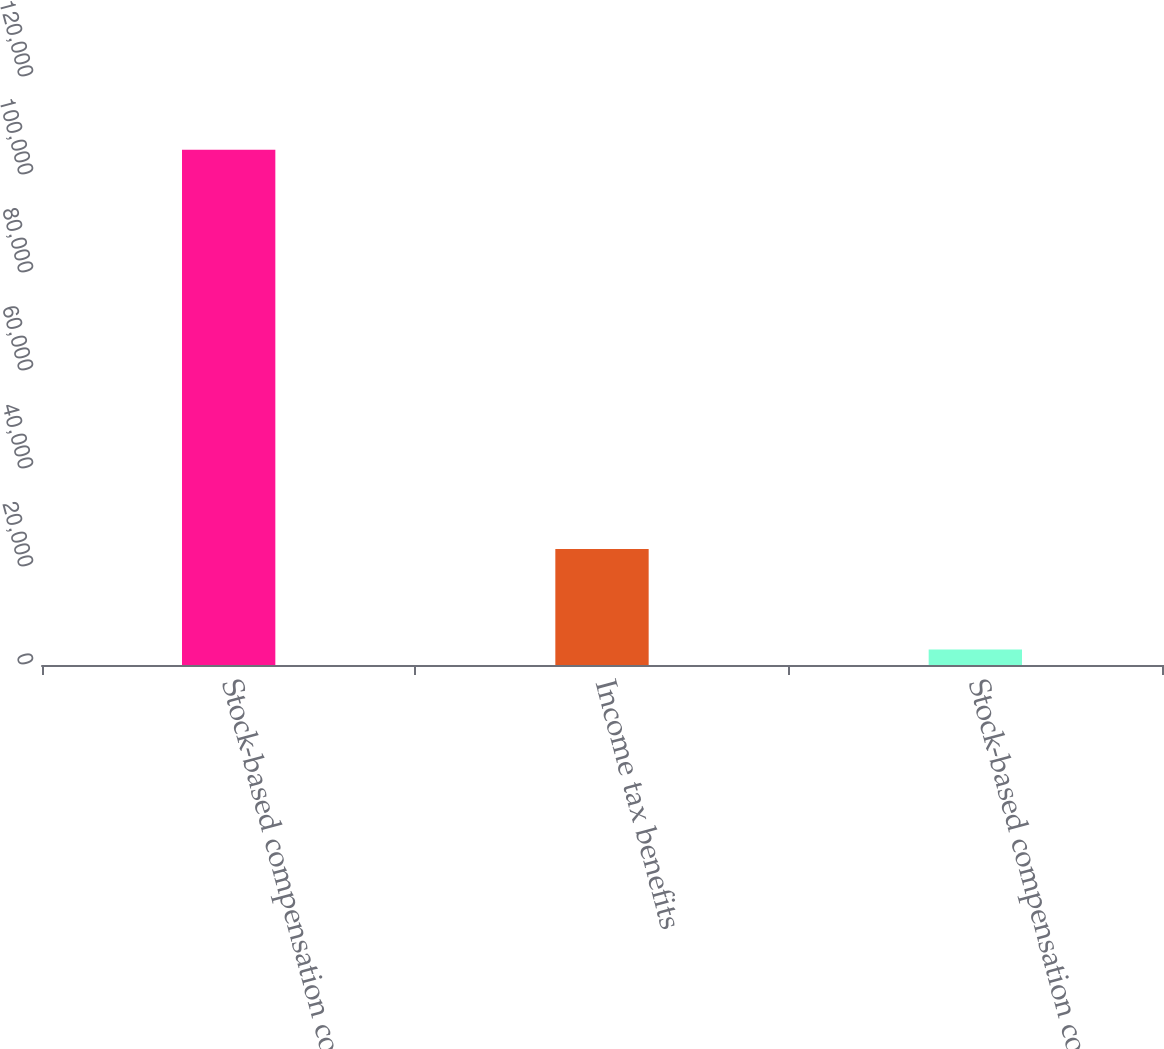<chart> <loc_0><loc_0><loc_500><loc_500><bar_chart><fcel>Stock-based compensation cost<fcel>Income tax benefits<fcel>Stock-based compensation costs<nl><fcel>105157<fcel>23650<fcel>3165<nl></chart> 